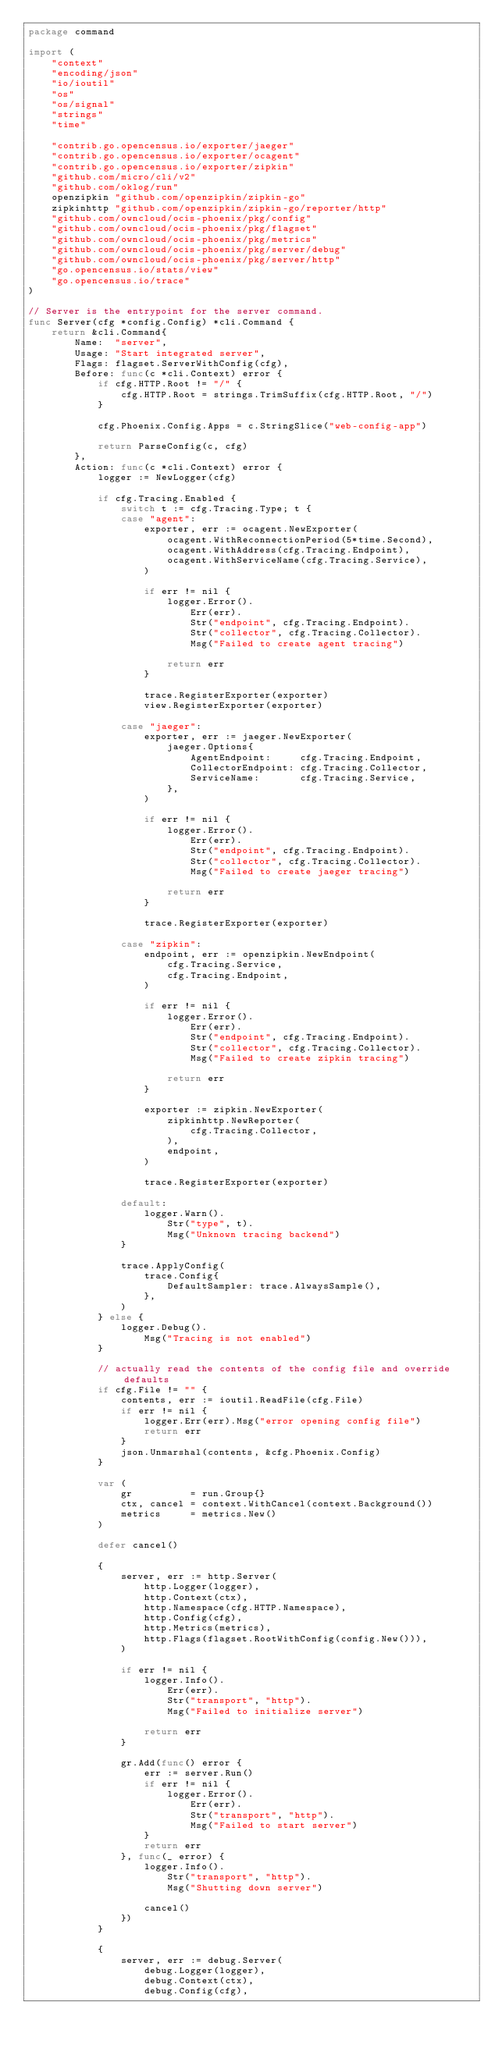Convert code to text. <code><loc_0><loc_0><loc_500><loc_500><_Go_>package command

import (
	"context"
	"encoding/json"
	"io/ioutil"
	"os"
	"os/signal"
	"strings"
	"time"

	"contrib.go.opencensus.io/exporter/jaeger"
	"contrib.go.opencensus.io/exporter/ocagent"
	"contrib.go.opencensus.io/exporter/zipkin"
	"github.com/micro/cli/v2"
	"github.com/oklog/run"
	openzipkin "github.com/openzipkin/zipkin-go"
	zipkinhttp "github.com/openzipkin/zipkin-go/reporter/http"
	"github.com/owncloud/ocis-phoenix/pkg/config"
	"github.com/owncloud/ocis-phoenix/pkg/flagset"
	"github.com/owncloud/ocis-phoenix/pkg/metrics"
	"github.com/owncloud/ocis-phoenix/pkg/server/debug"
	"github.com/owncloud/ocis-phoenix/pkg/server/http"
	"go.opencensus.io/stats/view"
	"go.opencensus.io/trace"
)

// Server is the entrypoint for the server command.
func Server(cfg *config.Config) *cli.Command {
	return &cli.Command{
		Name:  "server",
		Usage: "Start integrated server",
		Flags: flagset.ServerWithConfig(cfg),
		Before: func(c *cli.Context) error {
			if cfg.HTTP.Root != "/" {
				cfg.HTTP.Root = strings.TrimSuffix(cfg.HTTP.Root, "/")
			}

			cfg.Phoenix.Config.Apps = c.StringSlice("web-config-app")

			return ParseConfig(c, cfg)
		},
		Action: func(c *cli.Context) error {
			logger := NewLogger(cfg)

			if cfg.Tracing.Enabled {
				switch t := cfg.Tracing.Type; t {
				case "agent":
					exporter, err := ocagent.NewExporter(
						ocagent.WithReconnectionPeriod(5*time.Second),
						ocagent.WithAddress(cfg.Tracing.Endpoint),
						ocagent.WithServiceName(cfg.Tracing.Service),
					)

					if err != nil {
						logger.Error().
							Err(err).
							Str("endpoint", cfg.Tracing.Endpoint).
							Str("collector", cfg.Tracing.Collector).
							Msg("Failed to create agent tracing")

						return err
					}

					trace.RegisterExporter(exporter)
					view.RegisterExporter(exporter)

				case "jaeger":
					exporter, err := jaeger.NewExporter(
						jaeger.Options{
							AgentEndpoint:     cfg.Tracing.Endpoint,
							CollectorEndpoint: cfg.Tracing.Collector,
							ServiceName:       cfg.Tracing.Service,
						},
					)

					if err != nil {
						logger.Error().
							Err(err).
							Str("endpoint", cfg.Tracing.Endpoint).
							Str("collector", cfg.Tracing.Collector).
							Msg("Failed to create jaeger tracing")

						return err
					}

					trace.RegisterExporter(exporter)

				case "zipkin":
					endpoint, err := openzipkin.NewEndpoint(
						cfg.Tracing.Service,
						cfg.Tracing.Endpoint,
					)

					if err != nil {
						logger.Error().
							Err(err).
							Str("endpoint", cfg.Tracing.Endpoint).
							Str("collector", cfg.Tracing.Collector).
							Msg("Failed to create zipkin tracing")

						return err
					}

					exporter := zipkin.NewExporter(
						zipkinhttp.NewReporter(
							cfg.Tracing.Collector,
						),
						endpoint,
					)

					trace.RegisterExporter(exporter)

				default:
					logger.Warn().
						Str("type", t).
						Msg("Unknown tracing backend")
				}

				trace.ApplyConfig(
					trace.Config{
						DefaultSampler: trace.AlwaysSample(),
					},
				)
			} else {
				logger.Debug().
					Msg("Tracing is not enabled")
			}

			// actually read the contents of the config file and override defaults
			if cfg.File != "" {
				contents, err := ioutil.ReadFile(cfg.File)
				if err != nil {
					logger.Err(err).Msg("error opening config file")
					return err
				}
				json.Unmarshal(contents, &cfg.Phoenix.Config)
			}

			var (
				gr          = run.Group{}
				ctx, cancel = context.WithCancel(context.Background())
				metrics     = metrics.New()
			)

			defer cancel()

			{
				server, err := http.Server(
					http.Logger(logger),
					http.Context(ctx),
					http.Namespace(cfg.HTTP.Namespace),
					http.Config(cfg),
					http.Metrics(metrics),
					http.Flags(flagset.RootWithConfig(config.New())),
				)

				if err != nil {
					logger.Info().
						Err(err).
						Str("transport", "http").
						Msg("Failed to initialize server")

					return err
				}

				gr.Add(func() error {
					err := server.Run()
					if err != nil {
						logger.Error().
							Err(err).
							Str("transport", "http").
							Msg("Failed to start server")
					}
					return err
				}, func(_ error) {
					logger.Info().
						Str("transport", "http").
						Msg("Shutting down server")

					cancel()
				})
			}

			{
				server, err := debug.Server(
					debug.Logger(logger),
					debug.Context(ctx),
					debug.Config(cfg),</code> 